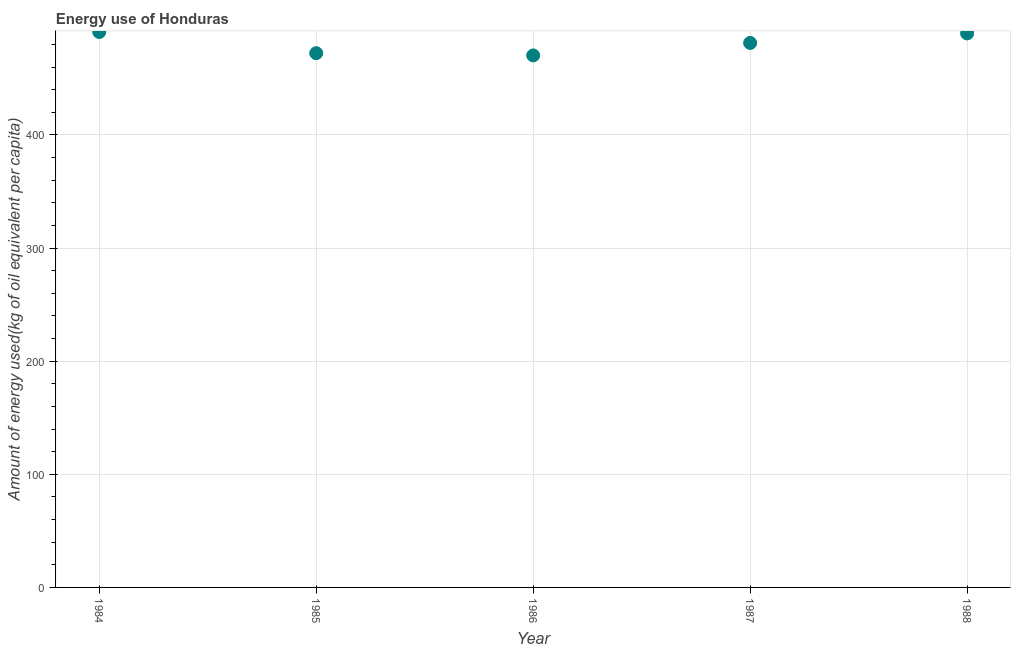What is the amount of energy used in 1987?
Make the answer very short. 481.32. Across all years, what is the maximum amount of energy used?
Provide a succinct answer. 490.99. Across all years, what is the minimum amount of energy used?
Keep it short and to the point. 470.29. In which year was the amount of energy used minimum?
Your response must be concise. 1986. What is the sum of the amount of energy used?
Make the answer very short. 2404.58. What is the difference between the amount of energy used in 1984 and 1987?
Keep it short and to the point. 9.67. What is the average amount of energy used per year?
Offer a very short reply. 480.92. What is the median amount of energy used?
Give a very brief answer. 481.32. In how many years, is the amount of energy used greater than 280 kg?
Offer a very short reply. 5. What is the ratio of the amount of energy used in 1984 to that in 1986?
Provide a succinct answer. 1.04. What is the difference between the highest and the second highest amount of energy used?
Keep it short and to the point. 1.27. What is the difference between the highest and the lowest amount of energy used?
Your response must be concise. 20.7. Does the amount of energy used monotonically increase over the years?
Give a very brief answer. No. How many dotlines are there?
Give a very brief answer. 1. How many years are there in the graph?
Keep it short and to the point. 5. What is the difference between two consecutive major ticks on the Y-axis?
Provide a succinct answer. 100. Does the graph contain any zero values?
Your response must be concise. No. What is the title of the graph?
Your answer should be compact. Energy use of Honduras. What is the label or title of the Y-axis?
Make the answer very short. Amount of energy used(kg of oil equivalent per capita). What is the Amount of energy used(kg of oil equivalent per capita) in 1984?
Offer a terse response. 490.99. What is the Amount of energy used(kg of oil equivalent per capita) in 1985?
Your response must be concise. 472.27. What is the Amount of energy used(kg of oil equivalent per capita) in 1986?
Provide a short and direct response. 470.29. What is the Amount of energy used(kg of oil equivalent per capita) in 1987?
Your answer should be very brief. 481.32. What is the Amount of energy used(kg of oil equivalent per capita) in 1988?
Your response must be concise. 489.72. What is the difference between the Amount of energy used(kg of oil equivalent per capita) in 1984 and 1985?
Your response must be concise. 18.72. What is the difference between the Amount of energy used(kg of oil equivalent per capita) in 1984 and 1986?
Your answer should be very brief. 20.7. What is the difference between the Amount of energy used(kg of oil equivalent per capita) in 1984 and 1987?
Make the answer very short. 9.67. What is the difference between the Amount of energy used(kg of oil equivalent per capita) in 1984 and 1988?
Keep it short and to the point. 1.27. What is the difference between the Amount of energy used(kg of oil equivalent per capita) in 1985 and 1986?
Your response must be concise. 1.98. What is the difference between the Amount of energy used(kg of oil equivalent per capita) in 1985 and 1987?
Provide a short and direct response. -9.05. What is the difference between the Amount of energy used(kg of oil equivalent per capita) in 1985 and 1988?
Your answer should be very brief. -17.46. What is the difference between the Amount of energy used(kg of oil equivalent per capita) in 1986 and 1987?
Your answer should be compact. -11.03. What is the difference between the Amount of energy used(kg of oil equivalent per capita) in 1986 and 1988?
Keep it short and to the point. -19.44. What is the difference between the Amount of energy used(kg of oil equivalent per capita) in 1987 and 1988?
Your response must be concise. -8.4. What is the ratio of the Amount of energy used(kg of oil equivalent per capita) in 1984 to that in 1985?
Offer a terse response. 1.04. What is the ratio of the Amount of energy used(kg of oil equivalent per capita) in 1984 to that in 1986?
Your answer should be compact. 1.04. What is the ratio of the Amount of energy used(kg of oil equivalent per capita) in 1984 to that in 1988?
Keep it short and to the point. 1. What is the ratio of the Amount of energy used(kg of oil equivalent per capita) in 1986 to that in 1988?
Your answer should be very brief. 0.96. What is the ratio of the Amount of energy used(kg of oil equivalent per capita) in 1987 to that in 1988?
Offer a terse response. 0.98. 